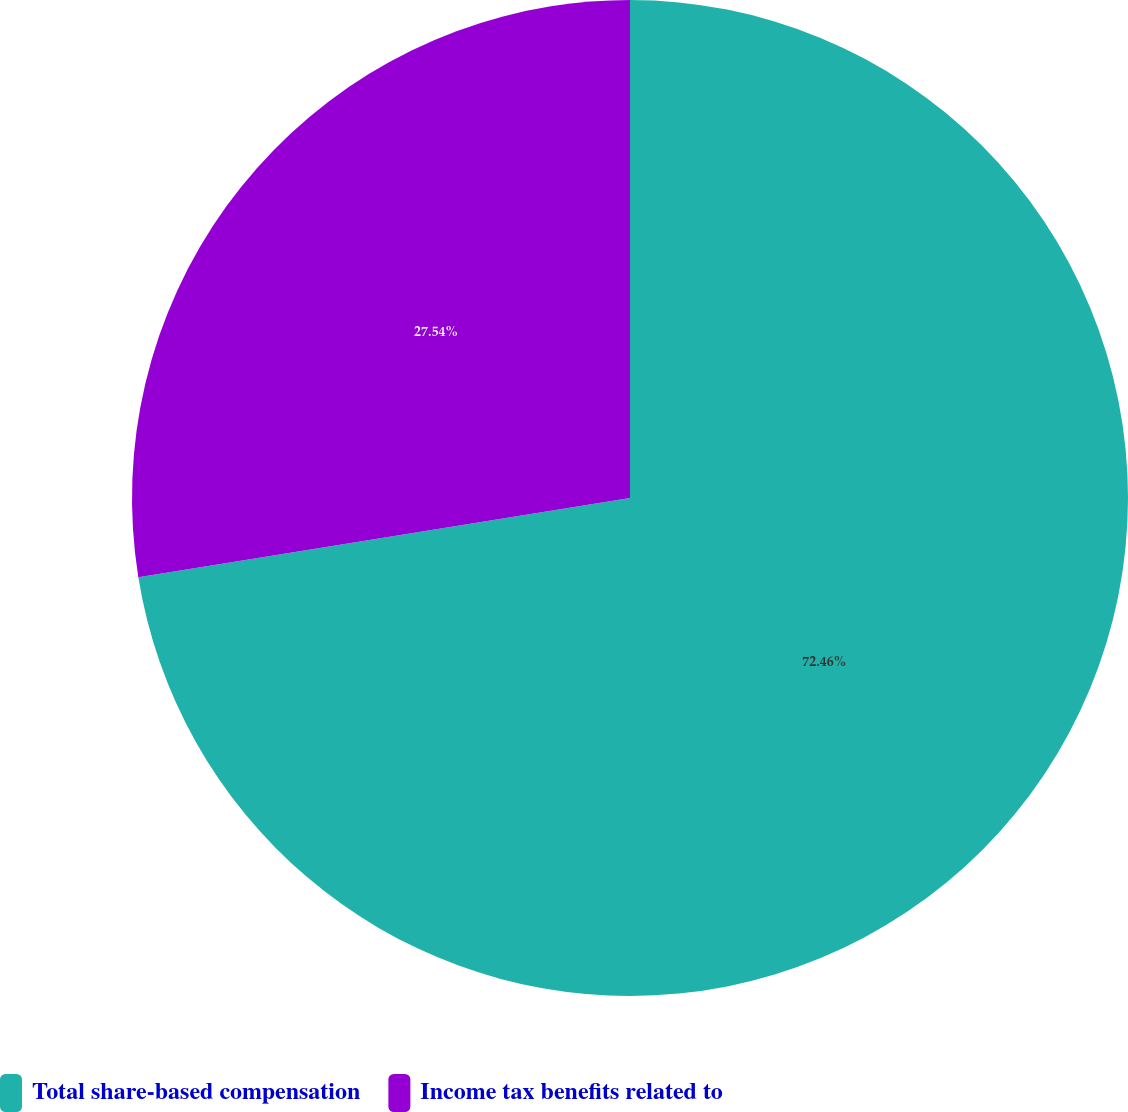Convert chart. <chart><loc_0><loc_0><loc_500><loc_500><pie_chart><fcel>Total share-based compensation<fcel>Income tax benefits related to<nl><fcel>72.46%<fcel>27.54%<nl></chart> 